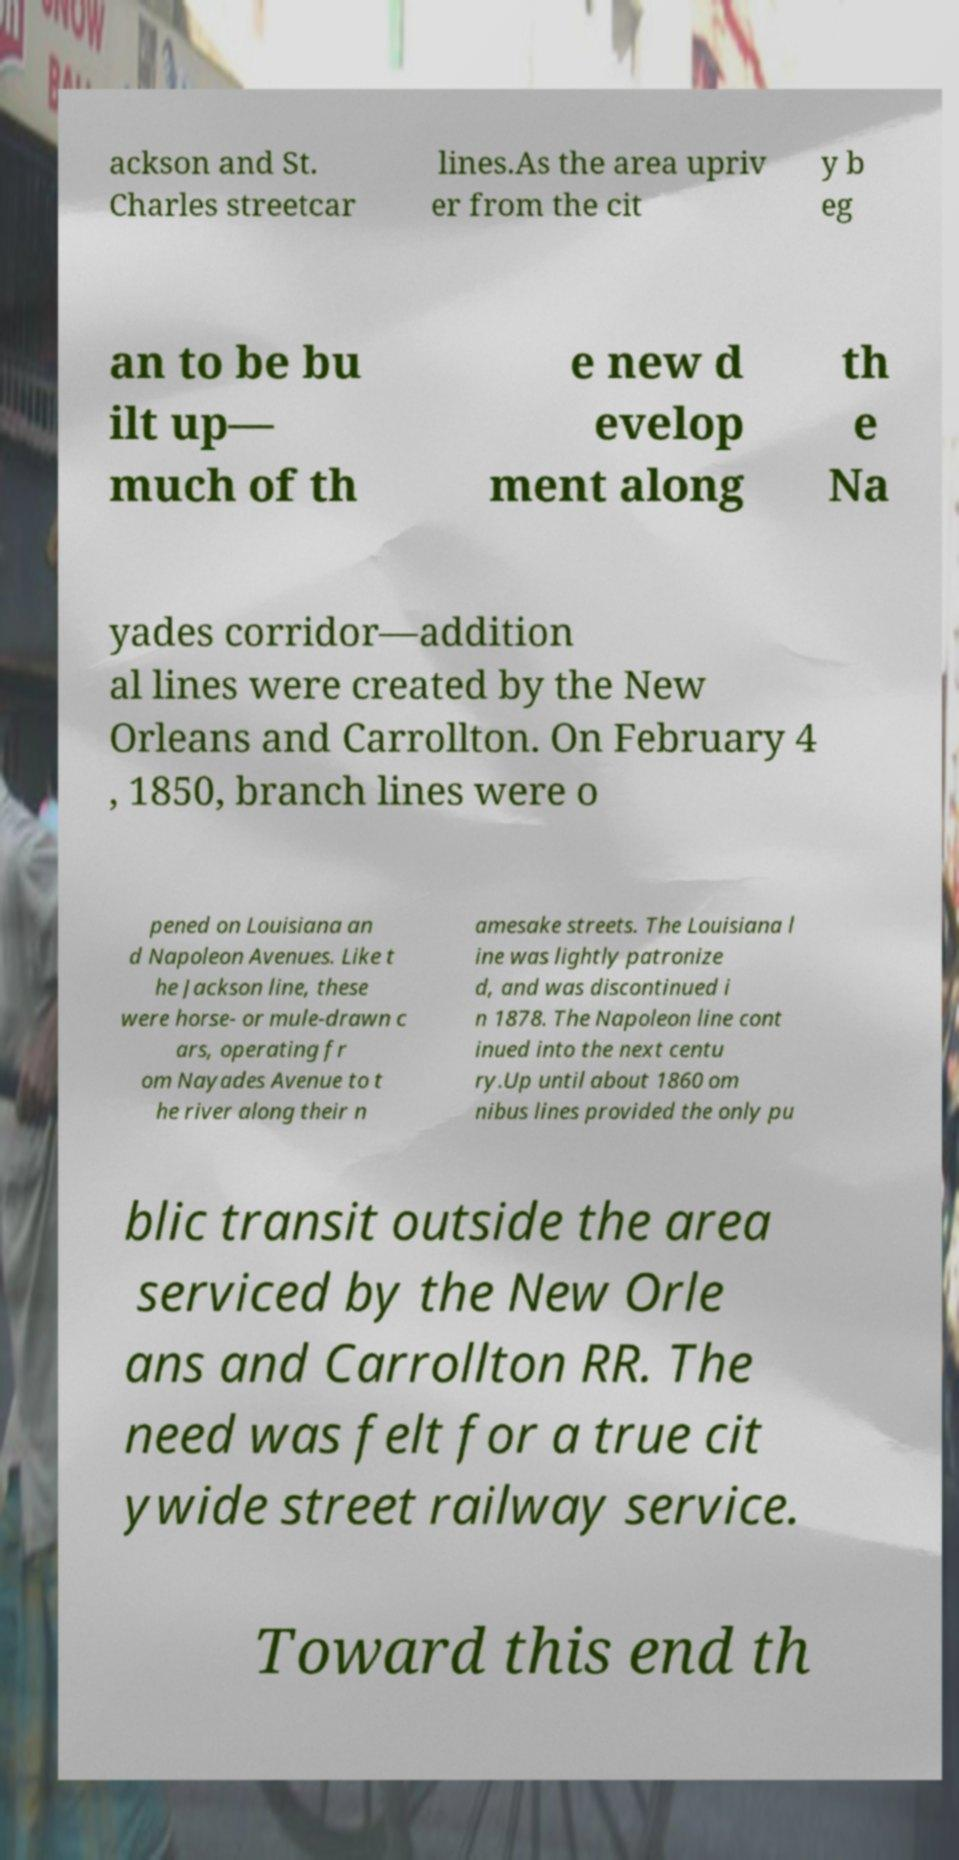Could you assist in decoding the text presented in this image and type it out clearly? ackson and St. Charles streetcar lines.As the area upriv er from the cit y b eg an to be bu ilt up— much of th e new d evelop ment along th e Na yades corridor—addition al lines were created by the New Orleans and Carrollton. On February 4 , 1850, branch lines were o pened on Louisiana an d Napoleon Avenues. Like t he Jackson line, these were horse- or mule-drawn c ars, operating fr om Nayades Avenue to t he river along their n amesake streets. The Louisiana l ine was lightly patronize d, and was discontinued i n 1878. The Napoleon line cont inued into the next centu ry.Up until about 1860 om nibus lines provided the only pu blic transit outside the area serviced by the New Orle ans and Carrollton RR. The need was felt for a true cit ywide street railway service. Toward this end th 